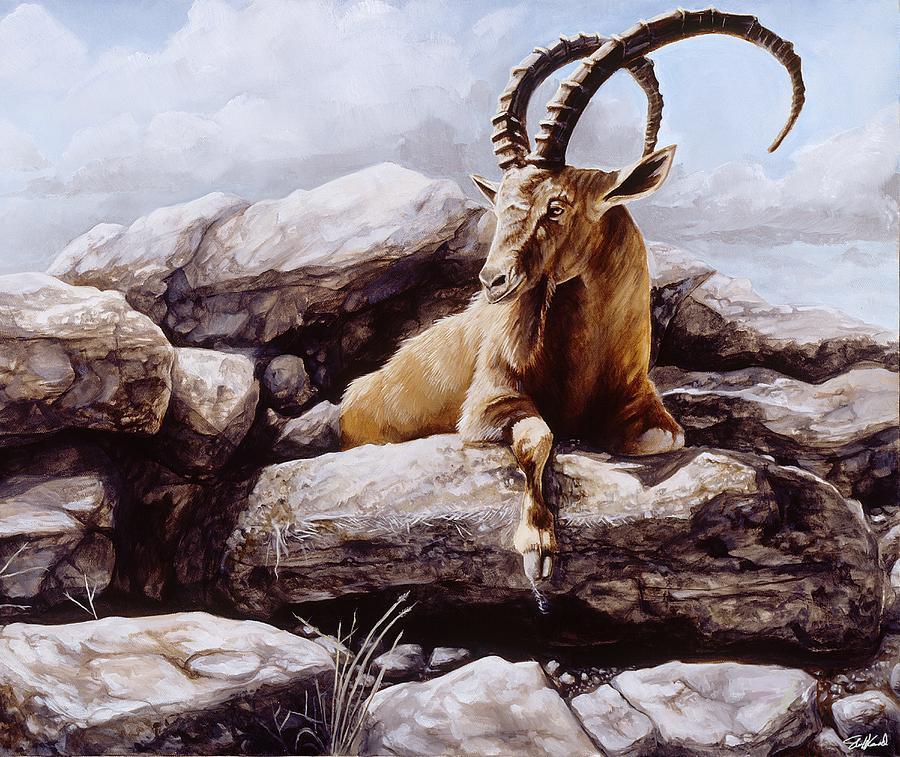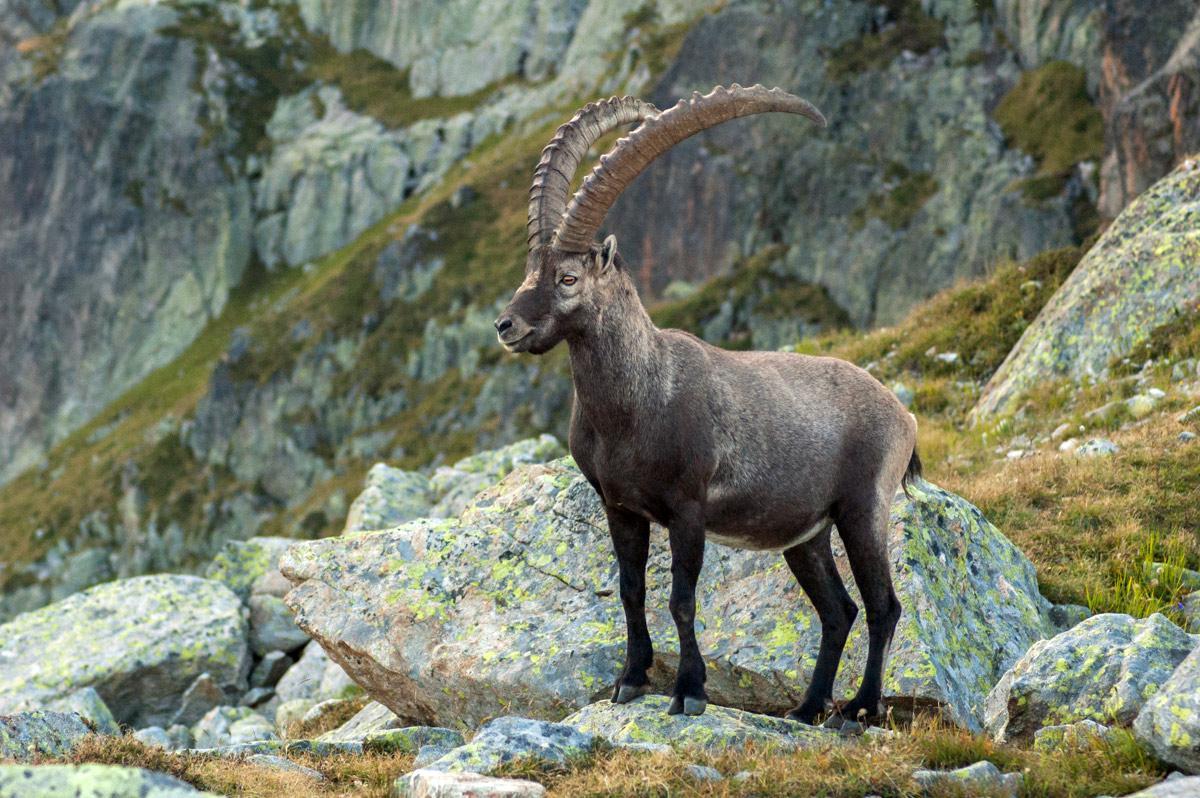The first image is the image on the left, the second image is the image on the right. Examine the images to the left and right. Is the description "In one image an animal with long, curved horns is standing in a rocky area, while a similar animal in the other image is lying down with its head erect." accurate? Answer yes or no. Yes. The first image is the image on the left, the second image is the image on the right. For the images displayed, is the sentence "Each image depicts exactly one long-horned hooved animal." factually correct? Answer yes or no. Yes. 